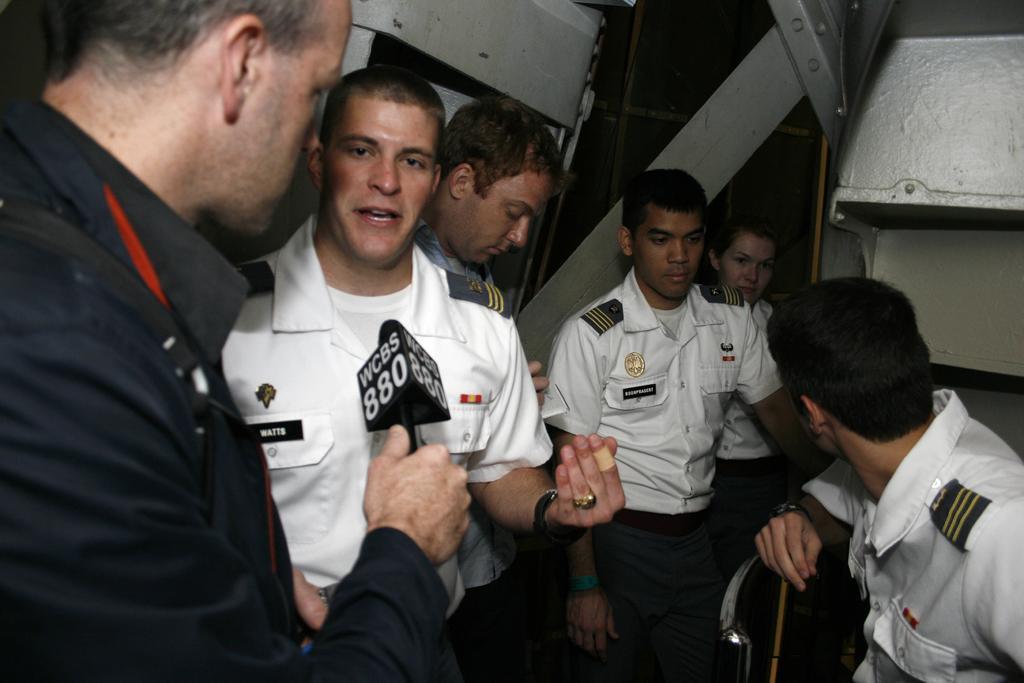How would you summarize this image in a sentence or two? In this image I can see five persons in a uniform and one person is holding a mike in hand. In the background I can see metal rods. This image is taken may be in a building. 